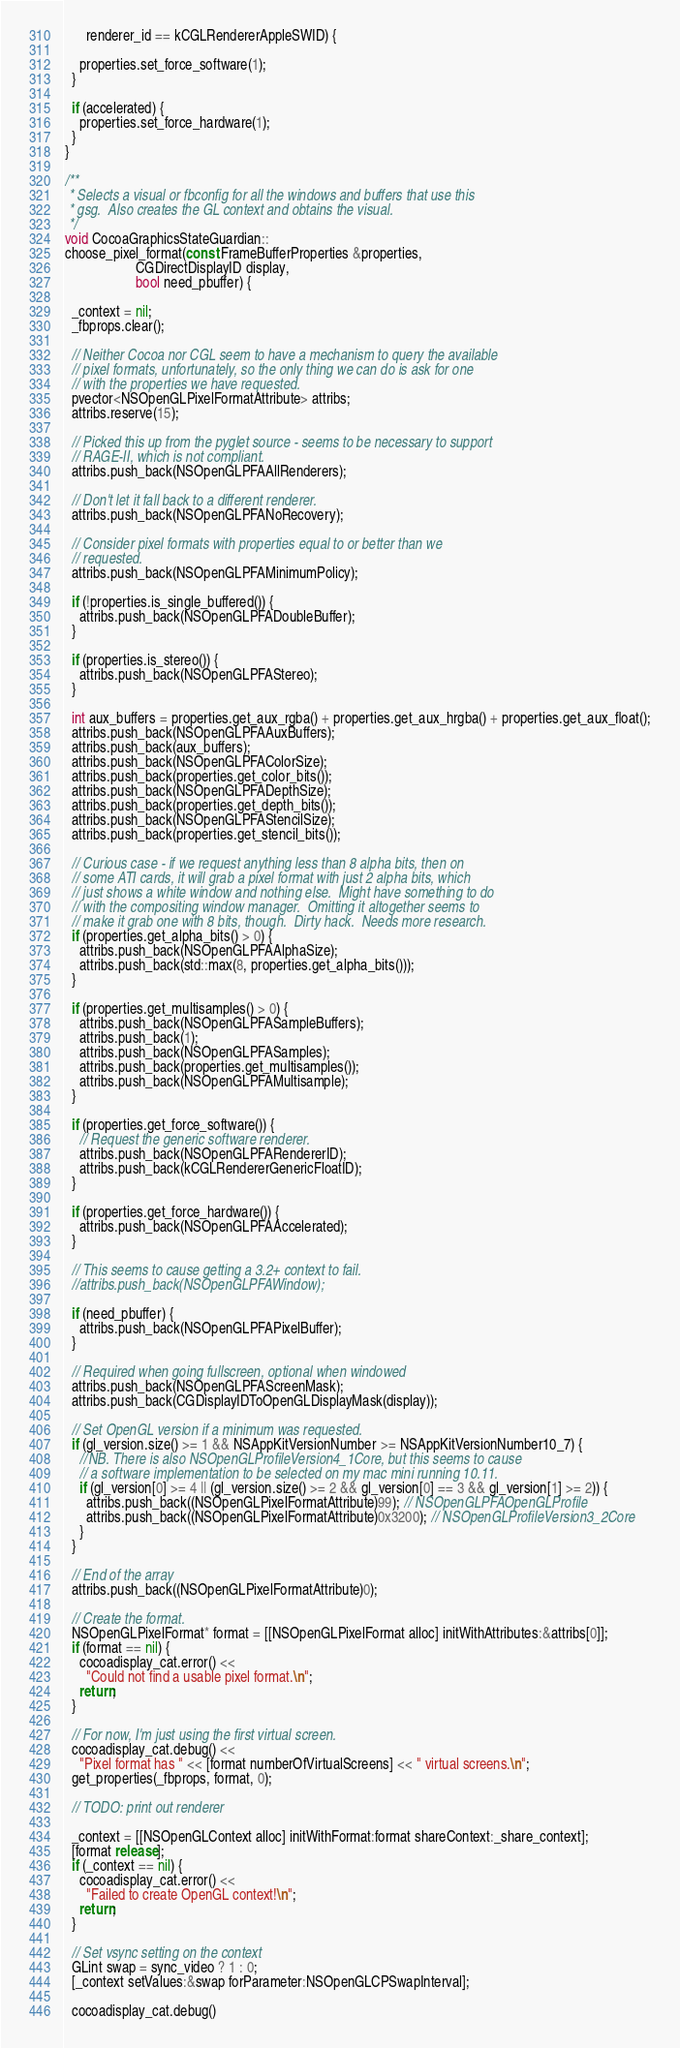<code> <loc_0><loc_0><loc_500><loc_500><_ObjectiveC_>      renderer_id == kCGLRendererAppleSWID) {

    properties.set_force_software(1);
  }

  if (accelerated) {
    properties.set_force_hardware(1);
  }
}

/**
 * Selects a visual or fbconfig for all the windows and buffers that use this
 * gsg.  Also creates the GL context and obtains the visual.
 */
void CocoaGraphicsStateGuardian::
choose_pixel_format(const FrameBufferProperties &properties,
                    CGDirectDisplayID display,
                    bool need_pbuffer) {

  _context = nil;
  _fbprops.clear();

  // Neither Cocoa nor CGL seem to have a mechanism to query the available
  // pixel formats, unfortunately, so the only thing we can do is ask for one
  // with the properties we have requested.
  pvector<NSOpenGLPixelFormatAttribute> attribs;
  attribs.reserve(15);

  // Picked this up from the pyglet source - seems to be necessary to support
  // RAGE-II, which is not compliant.
  attribs.push_back(NSOpenGLPFAAllRenderers);

  // Don't let it fall back to a different renderer.
  attribs.push_back(NSOpenGLPFANoRecovery);

  // Consider pixel formats with properties equal to or better than we
  // requested.
  attribs.push_back(NSOpenGLPFAMinimumPolicy);

  if (!properties.is_single_buffered()) {
    attribs.push_back(NSOpenGLPFADoubleBuffer);
  }

  if (properties.is_stereo()) {
    attribs.push_back(NSOpenGLPFAStereo);
  }

  int aux_buffers = properties.get_aux_rgba() + properties.get_aux_hrgba() + properties.get_aux_float();
  attribs.push_back(NSOpenGLPFAAuxBuffers);
  attribs.push_back(aux_buffers);
  attribs.push_back(NSOpenGLPFAColorSize);
  attribs.push_back(properties.get_color_bits());
  attribs.push_back(NSOpenGLPFADepthSize);
  attribs.push_back(properties.get_depth_bits());
  attribs.push_back(NSOpenGLPFAStencilSize);
  attribs.push_back(properties.get_stencil_bits());

  // Curious case - if we request anything less than 8 alpha bits, then on
  // some ATI cards, it will grab a pixel format with just 2 alpha bits, which
  // just shows a white window and nothing else.  Might have something to do
  // with the compositing window manager.  Omitting it altogether seems to
  // make it grab one with 8 bits, though.  Dirty hack.  Needs more research.
  if (properties.get_alpha_bits() > 0) {
    attribs.push_back(NSOpenGLPFAAlphaSize);
    attribs.push_back(std::max(8, properties.get_alpha_bits()));
  }

  if (properties.get_multisamples() > 0) {
    attribs.push_back(NSOpenGLPFASampleBuffers);
    attribs.push_back(1);
    attribs.push_back(NSOpenGLPFASamples);
    attribs.push_back(properties.get_multisamples());
    attribs.push_back(NSOpenGLPFAMultisample);
  }

  if (properties.get_force_software()) {
    // Request the generic software renderer.
    attribs.push_back(NSOpenGLPFARendererID);
    attribs.push_back(kCGLRendererGenericFloatID);
  }

  if (properties.get_force_hardware()) {
    attribs.push_back(NSOpenGLPFAAccelerated);
  }

  // This seems to cause getting a 3.2+ context to fail.
  //attribs.push_back(NSOpenGLPFAWindow);

  if (need_pbuffer) {
    attribs.push_back(NSOpenGLPFAPixelBuffer);
  }

  // Required when going fullscreen, optional when windowed
  attribs.push_back(NSOpenGLPFAScreenMask);
  attribs.push_back(CGDisplayIDToOpenGLDisplayMask(display));

  // Set OpenGL version if a minimum was requested.
  if (gl_version.size() >= 1 && NSAppKitVersionNumber >= NSAppKitVersionNumber10_7) {
    //NB. There is also NSOpenGLProfileVersion4_1Core, but this seems to cause
    // a software implementation to be selected on my mac mini running 10.11.
    if (gl_version[0] >= 4 || (gl_version.size() >= 2 && gl_version[0] == 3 && gl_version[1] >= 2)) {
      attribs.push_back((NSOpenGLPixelFormatAttribute)99); // NSOpenGLPFAOpenGLProfile
      attribs.push_back((NSOpenGLPixelFormatAttribute)0x3200); // NSOpenGLProfileVersion3_2Core
    }
  }

  // End of the array
  attribs.push_back((NSOpenGLPixelFormatAttribute)0);

  // Create the format.
  NSOpenGLPixelFormat* format = [[NSOpenGLPixelFormat alloc] initWithAttributes:&attribs[0]];
  if (format == nil) {
    cocoadisplay_cat.error() <<
      "Could not find a usable pixel format.\n";
    return;
  }

  // For now, I'm just using the first virtual screen.
  cocoadisplay_cat.debug() <<
    "Pixel format has " << [format numberOfVirtualScreens] << " virtual screens.\n";
  get_properties(_fbprops, format, 0);

  // TODO: print out renderer

  _context = [[NSOpenGLContext alloc] initWithFormat:format shareContext:_share_context];
  [format release];
  if (_context == nil) {
    cocoadisplay_cat.error() <<
      "Failed to create OpenGL context!\n";
    return;
  }

  // Set vsync setting on the context
  GLint swap = sync_video ? 1 : 0;
  [_context setValues:&swap forParameter:NSOpenGLCPSwapInterval];

  cocoadisplay_cat.debug()</code> 